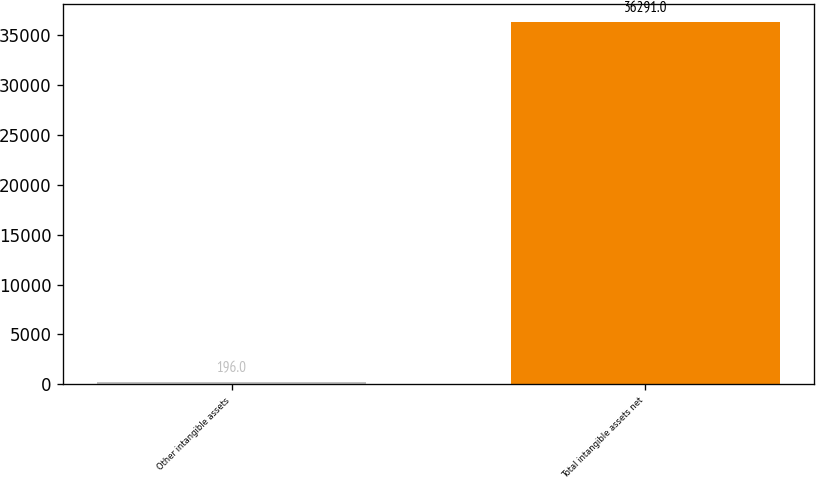Convert chart to OTSL. <chart><loc_0><loc_0><loc_500><loc_500><bar_chart><fcel>Other intangible assets<fcel>Total intangible assets net<nl><fcel>196<fcel>36291<nl></chart> 